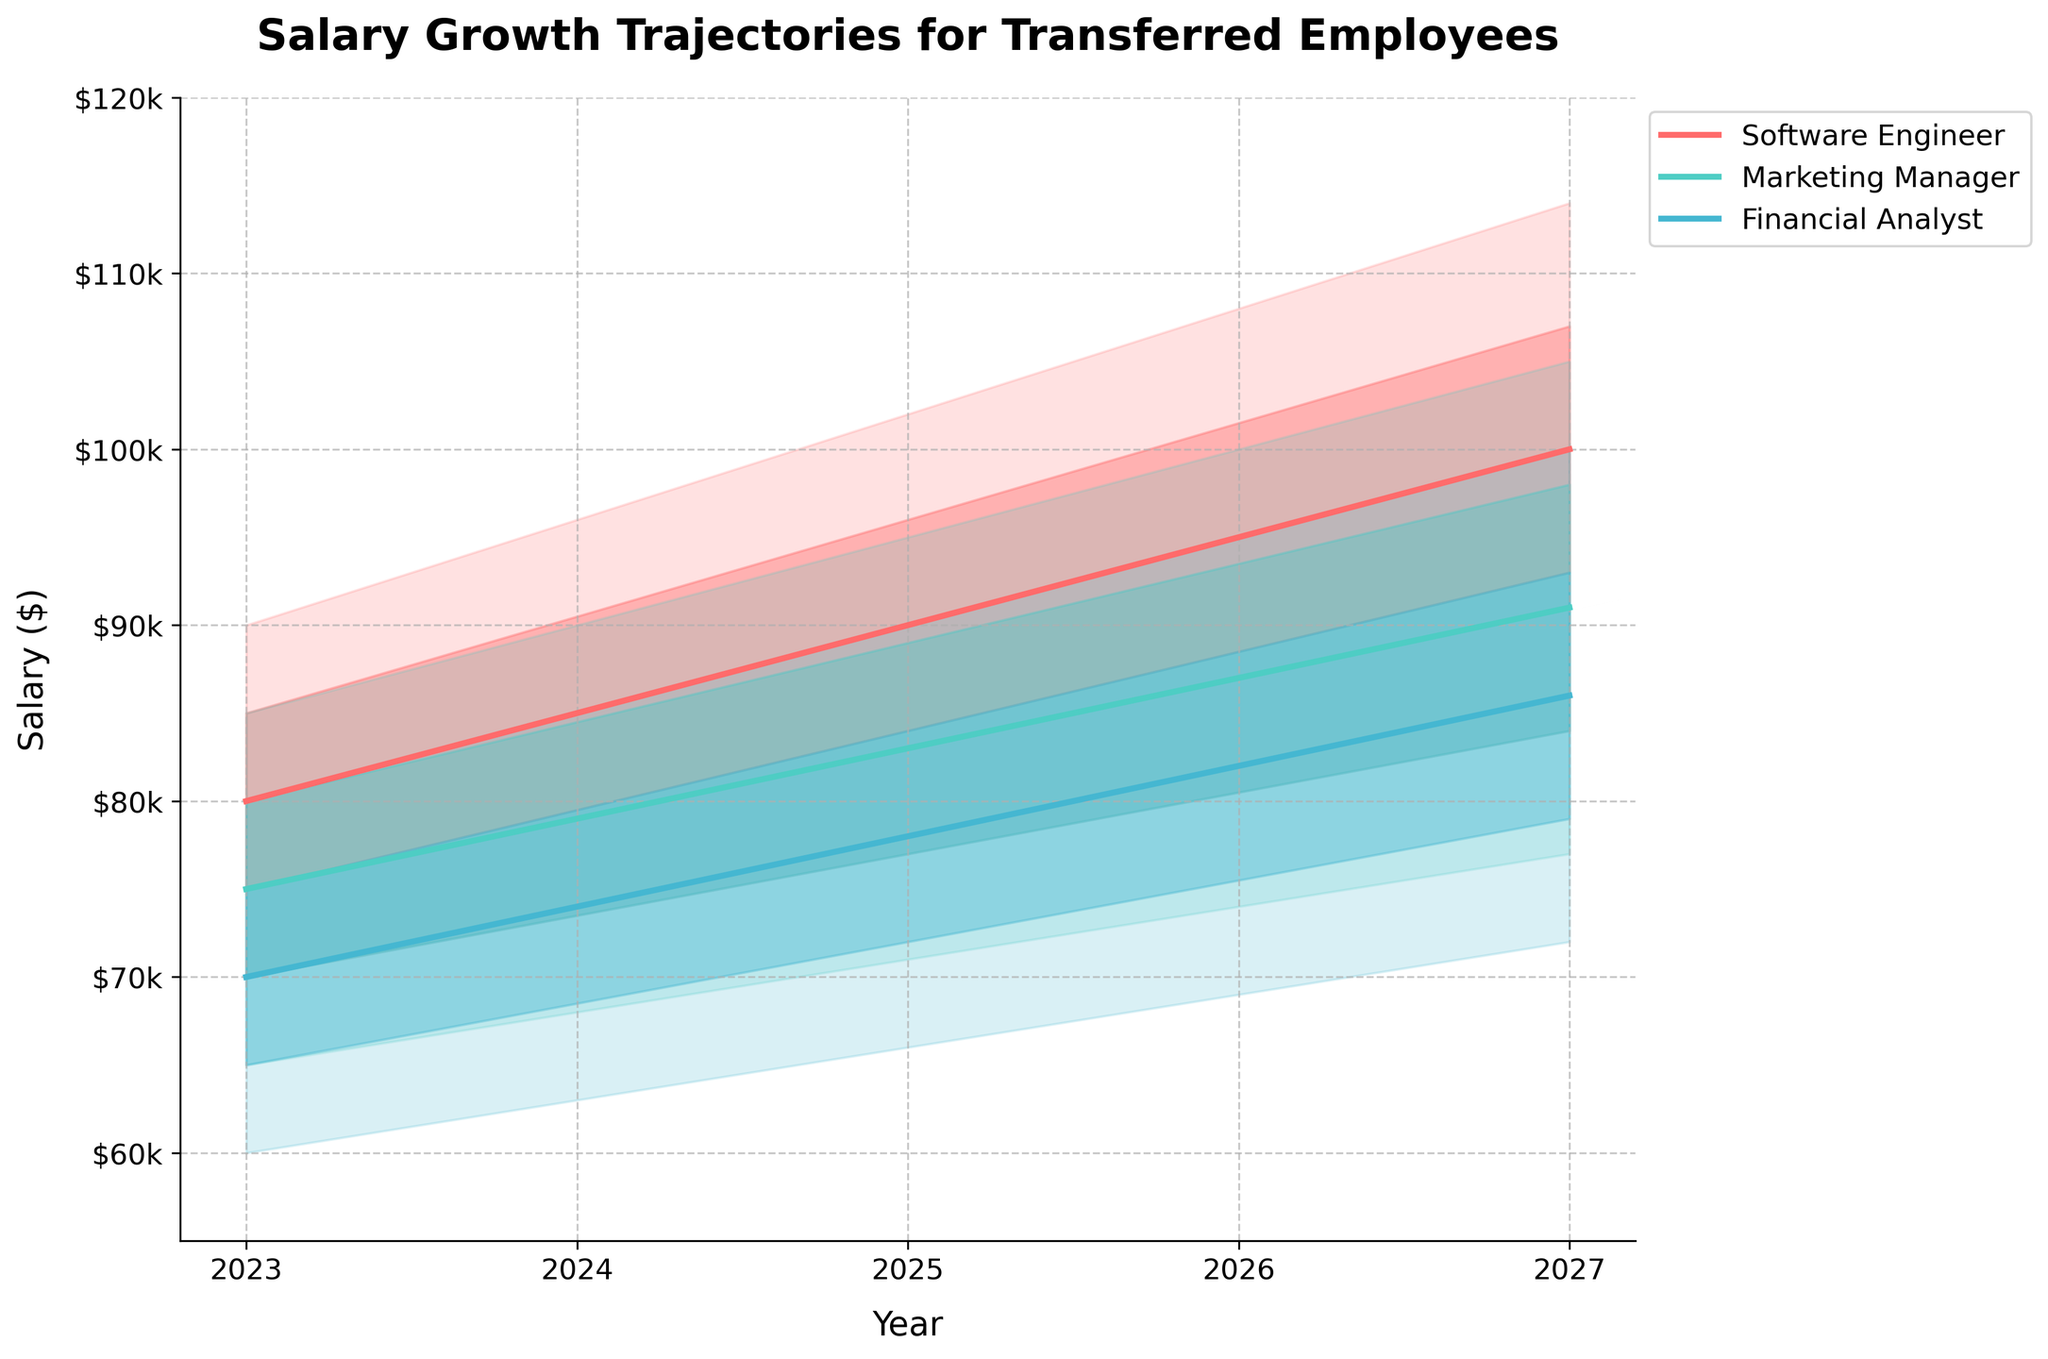What is the title of the figure? The title of the figure is usually located at the top of the chart. Here it states 'Salary Growth Trajectories for Transferred Employees', which indicates the subject of the data shown.
Answer: Salary Growth Trajectories for Transferred Employees What is the predicted median salary for Marketing Managers in 2024? To find this information, look for the intersection of the 'Marketing Manager' role and the year 2024, then identify the median salary value from the plot.
Answer: $79,000 How do the upper 90th salary percentiles for Software Engineers change between 2023 and 2027? Locate the 'Software Engineer' role and compare the upper 90th percentile values for each year from 2023 to 2027 on the Y-axis. The values are: $90,000 for 2023, $96,000 for 2024, $102,000 for 2025, $108,000 for 2026, and $114,000 for 2027.
Answer: It increases from $90,000 to $114,000 Which role has the highest median salary in 2025? To find this, compare the median salary values for Software Engineers, Marketing Managers, and Financial Analysts in 2025. The median salaries are $90,000, $83,000, and $78,000 respectively.
Answer: Software Engineer By how much does the median salary for Financial Analysts increase from 2023 to 2027? First, find the median salary for Financial Analysts in 2023 ($70,000) and in 2027 ($86,000). The increase is calculated as $86,000 - $70,000 = $16,000.
Answer: $16,000 What is the range of salaries for Marketing Managers in 2026? The range is calculated by subtracting the lower 10th percentile from the upper 90th percentile for the year 2026 for Marketing Managers. The values are $100,000 (upper 90th) and $74,000 (lower 10th). $100,000 - $74,000 = $26,000.
Answer: $26,000 Which job role has the narrowest salary range in 2023 and what is the range? Calculate the salary range for each role in 2023 by subtracting the lower 10th percentile from the upper 90th percentile. For Software Engineers: $90,000 - $70,000 = $20,000; Marketing Managers: $85,000 - $65,000 = $20,000; Financial Analysts: $80,000 - $60,000 = $20,000. All roles have the same salary range.
Answer: All three roles have a range of $20,000 What trend do you observe for the median salaries of all job roles from 2023 to 2027? Observe the median salary trajectories over the years. For Software Engineers, it increases from $80,000 to $100,000; for Marketing Managers, from $75,000 to $91,000; and for Financial Analysts, from $70,000 to $86,000. The trend is a steady increase in median salaries for all roles.
Answer: Steady increase 